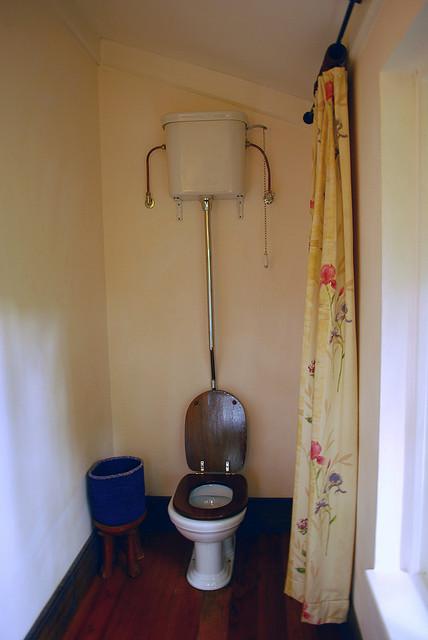What kind of print is on the curtain?
Answer briefly. Flower. Is the floor tiled?
Give a very brief answer. No. Why is the tank so high above the bowl?
Answer briefly. Gravity. What is the object in this picture's focus?
Answer briefly. Toilet. 